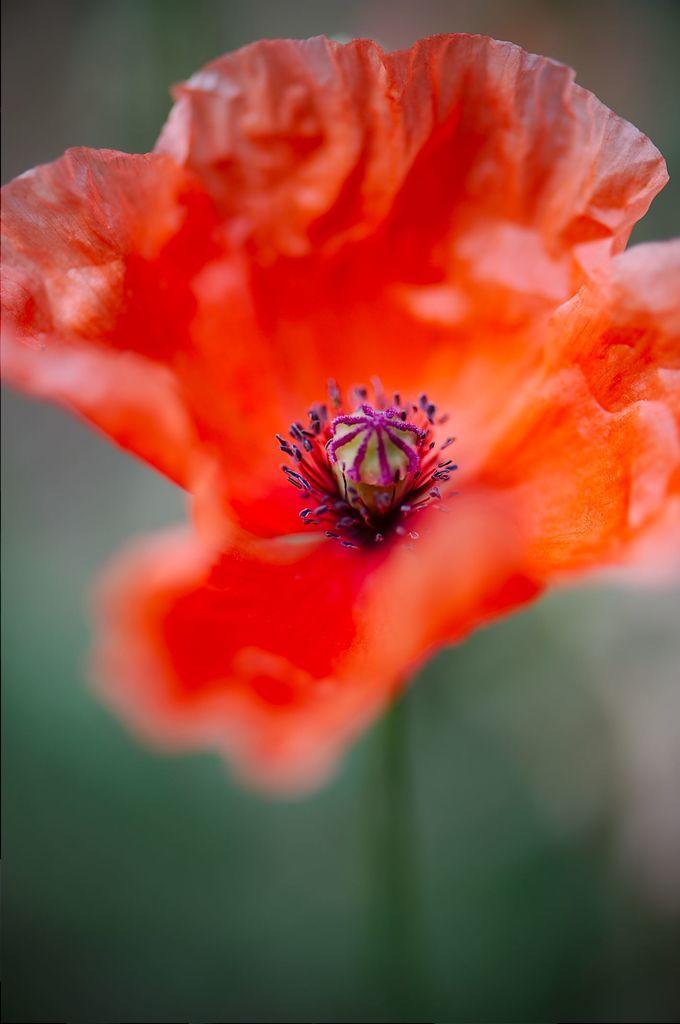Describe this image in one or two sentences. It is a flower in orange color. 